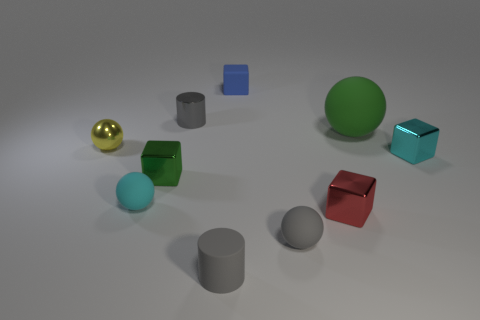Subtract all small gray spheres. How many spheres are left? 3 Subtract all green cubes. How many cubes are left? 3 Subtract all balls. How many objects are left? 6 Subtract 1 cylinders. How many cylinders are left? 1 Subtract 0 yellow blocks. How many objects are left? 10 Subtract all blue balls. Subtract all cyan blocks. How many balls are left? 4 Subtract all tiny cubes. Subtract all tiny cyan metal things. How many objects are left? 5 Add 4 gray rubber balls. How many gray rubber balls are left? 5 Add 3 blue matte spheres. How many blue matte spheres exist? 3 